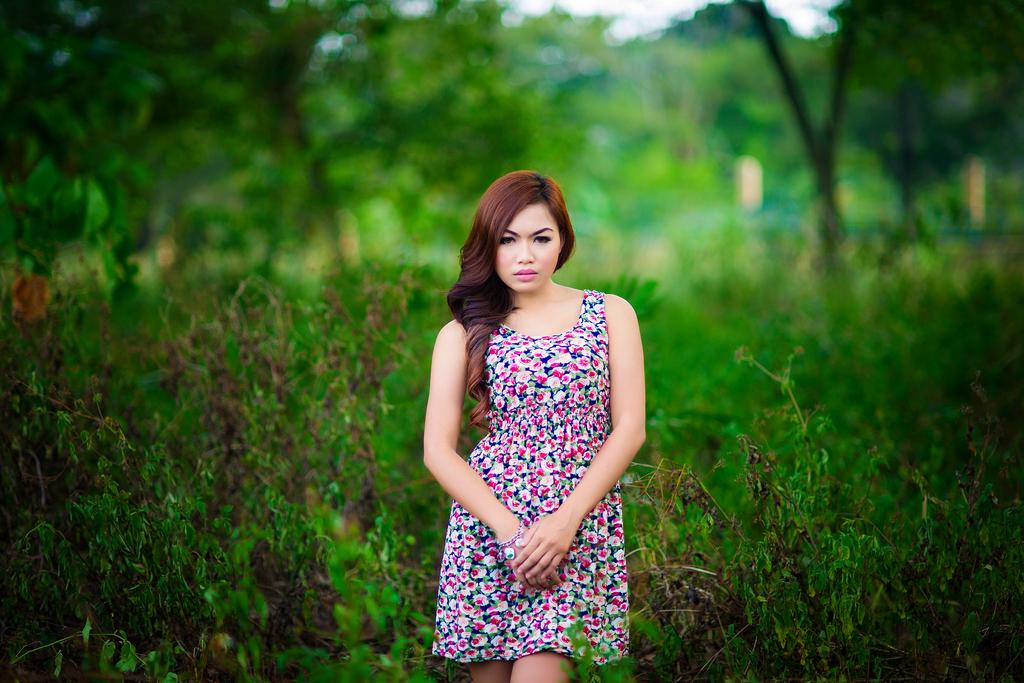Who is the main subject in the image? There is a girl in the image. What is the girl's position in the image? The girl is standing on the ground. What can be seen in the background of the image? There are plants and trees in the background of the image. What type of bun is the girl holding in the image? There is no bun present in the image; the girl is not holding anything. 